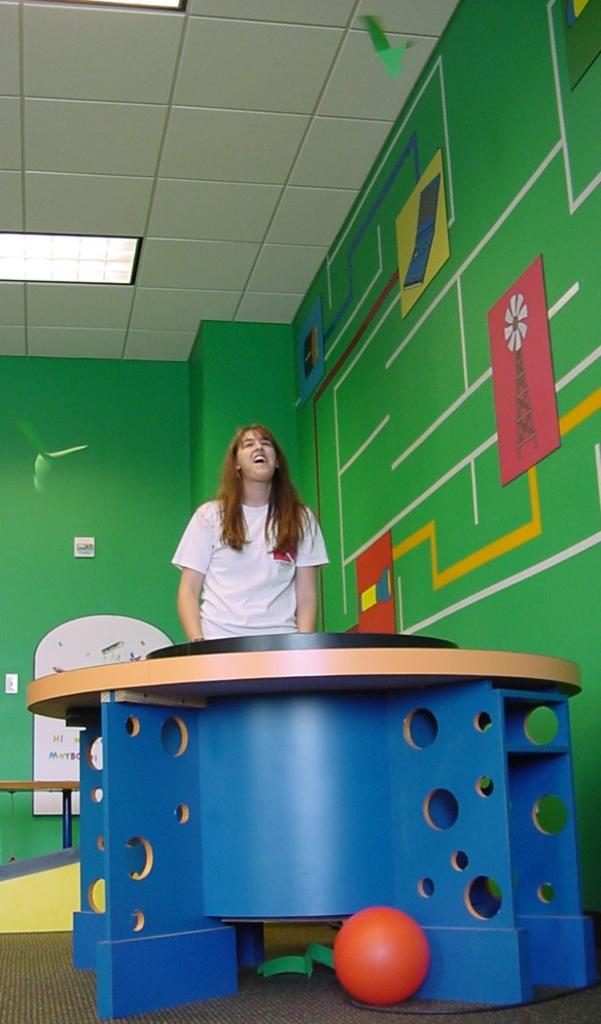Who is present in the image? There is a woman in the image. What is the woman doing in the image? The woman is standing in the image. What object can be seen near the woman? There is a table in the image. What is in front of the woman? There is a ball in front of the woman. What can be seen in the background of the image? There is a wall in the background of the image. What theory does the woman in the image propose? There is no indication in the image that the woman is proposing a theory. 